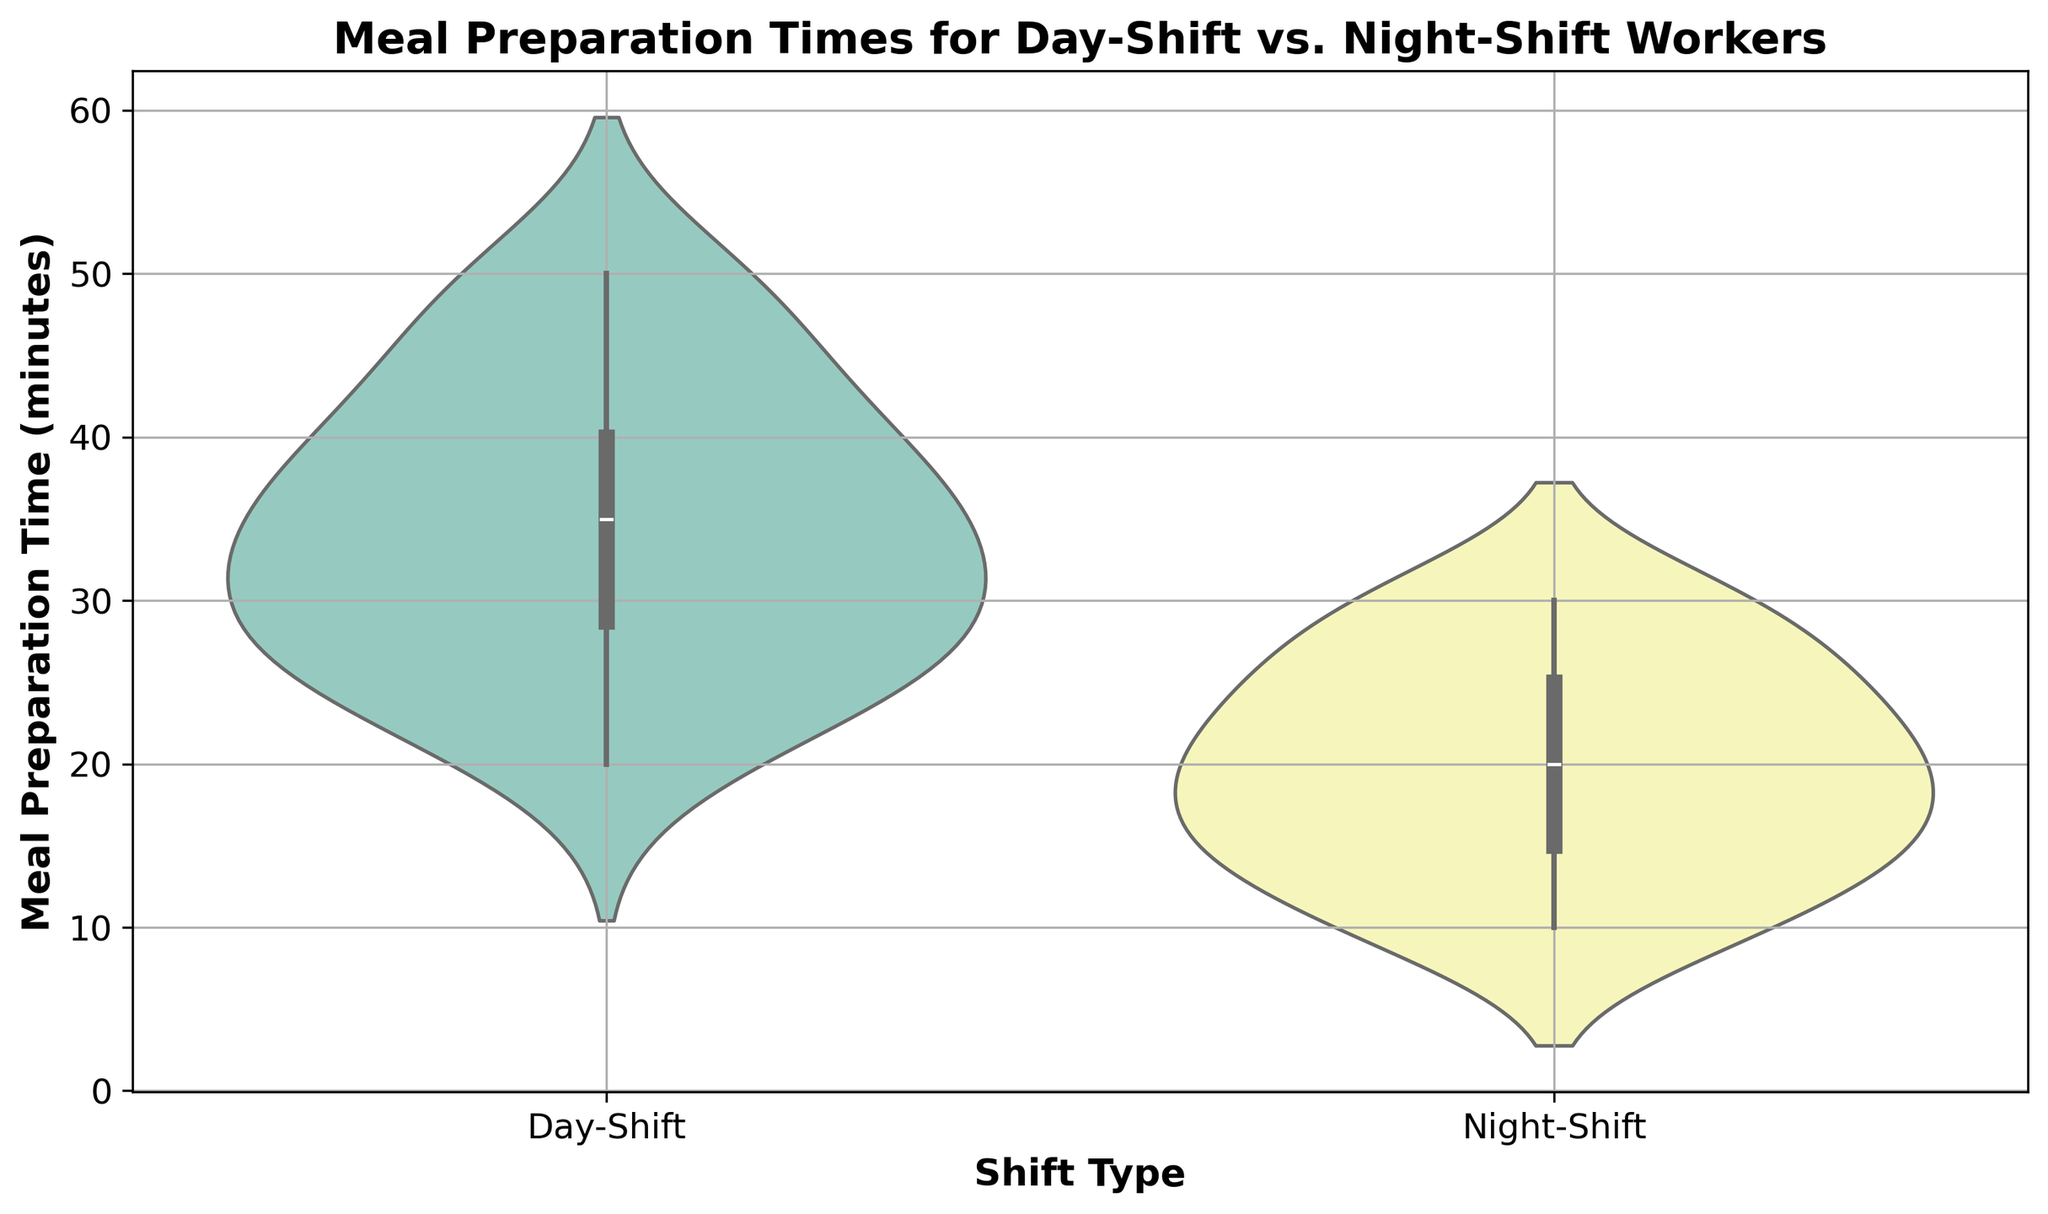What's the median meal preparation time for day-shift workers? The median is the middle value of an ordered data set. For day-shift workers, the ordered times are: 20, 25, 25, 25, 25, 30, 30, 30, 30, 35, 35, 35, 35, 40, 40, 40, 45, 45, 50, 50. The median is the average of the 10th (35) and 11th (35) values.
Answer: 35 Which group has a wider range of meal preparation times? The range is the difference between the maximum and minimum values. For day-shift workers, the range is 50 - 20 = 30 minutes. For night-shift workers, the range is 30 - 10 = 20 minutes.
Answer: Day-Shift Workers Which shift type shows more variability in meal preparation times? Variability can be inferred from the width and spread of the violin plot. A wider and more spread out violin indicates greater variability. Visually, the day-shift violin plot is broader and more spread out.
Answer: Day-Shift Workers What is the most common meal preparation time for night-shift workers? The most common time corresponds to the peak (widest part) of the violin plot. For night-shift workers, the peak is at 15 and 20 minutes.
Answer: 15 and 20 minutes Is there any overlap in meal preparation times between the two groups? Overlap is present if both groups have a common range in their violin plots. Both day-shift and night-shift workers have meal preparation times around 20 to 30 minutes.
Answer: Yes What can you infer about the meal preparation time for day-shift workers compared to night-shift workers? Day-shift workers generally have meal preparation times centered around 25-40 minutes, while night-shift workers' times are clustered around 15-25 minutes. This indicates longer prep times for day-shift workers.
Answer: Day-shift workers generally take longer Comparing the quartiles of both distributions, which group has a higher third quartile? The third quartile (Q3) is the value below which 75% of the data falls. This is higher up in more distributed, taller parts of the violin. Day-shift workers' Q3 is around 40 minutes while night-shift workers' Q3 is around 25 minutes.
Answer: Day-Shift Workers On average, who spends less time on meal preparation? The average can be inferred from the distribution centers of the violin plots. Night-shift workers tend to be centered around lower times (15-20 mins), whereas day-shift workers center around higher times (30-35 mins).
Answer: Night-Shift Workers 